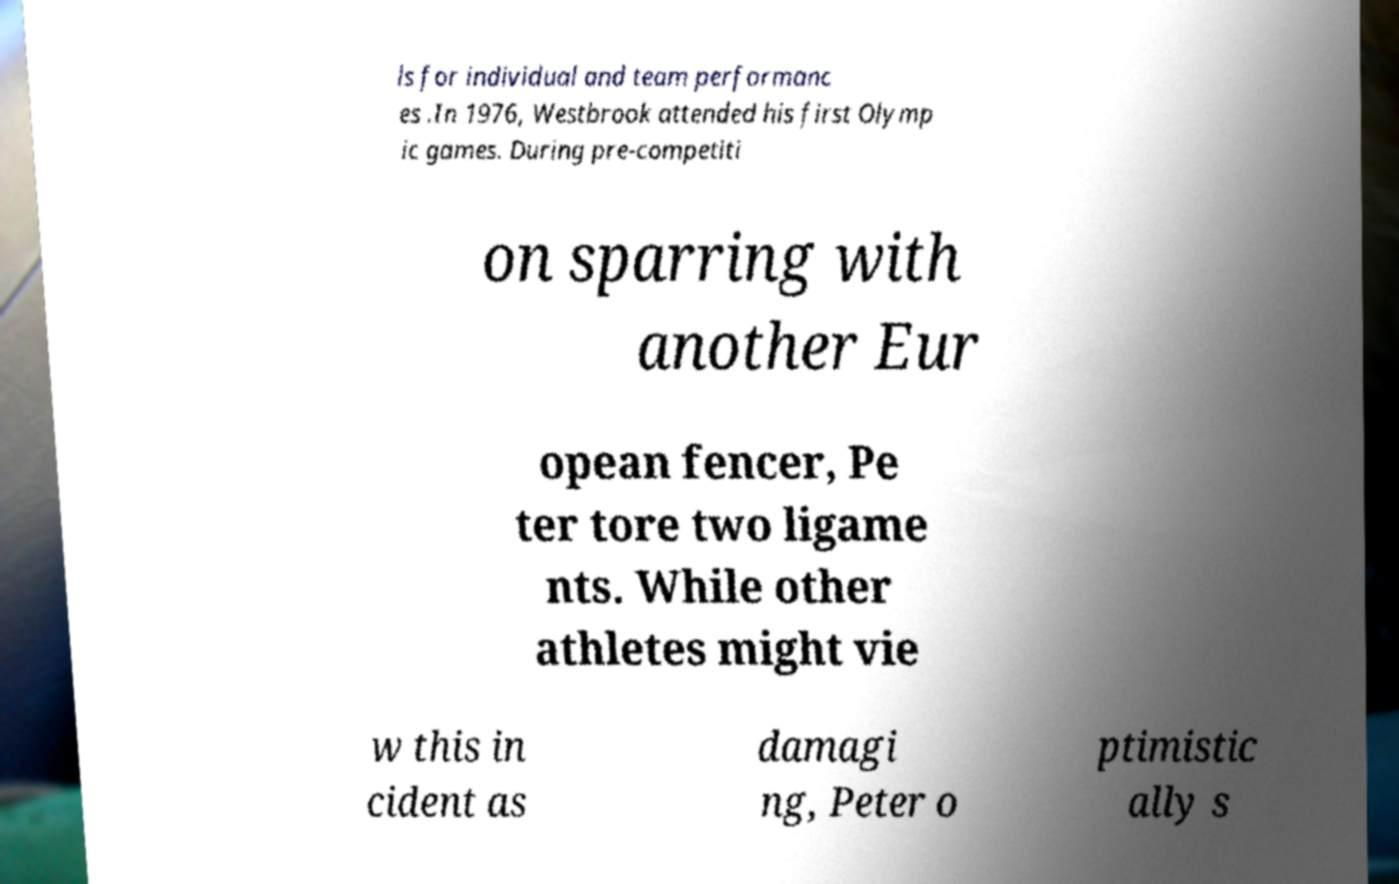Could you assist in decoding the text presented in this image and type it out clearly? ls for individual and team performanc es .In 1976, Westbrook attended his first Olymp ic games. During pre-competiti on sparring with another Eur opean fencer, Pe ter tore two ligame nts. While other athletes might vie w this in cident as damagi ng, Peter o ptimistic ally s 